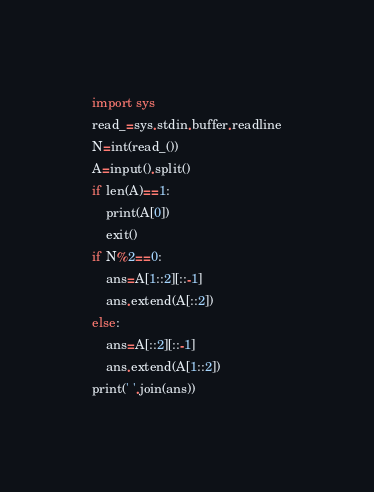Convert code to text. <code><loc_0><loc_0><loc_500><loc_500><_Python_>import sys
read_=sys.stdin.buffer.readline
N=int(read_())
A=input().split()
if len(A)==1:
    print(A[0])
    exit()
if N%2==0:
    ans=A[1::2][::-1]
    ans.extend(A[::2])
else:
    ans=A[::2][::-1]
    ans.extend(A[1::2])
print(' '.join(ans))</code> 